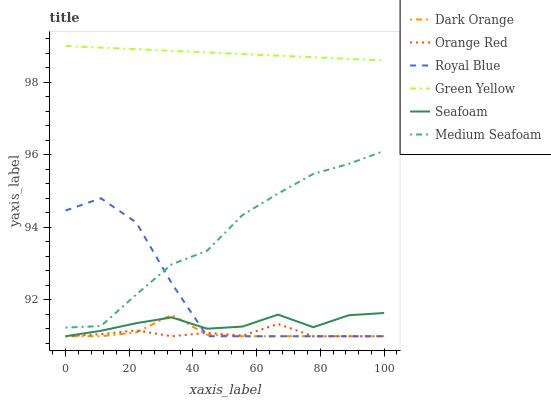Does Orange Red have the minimum area under the curve?
Answer yes or no. Yes. Does Green Yellow have the maximum area under the curve?
Answer yes or no. Yes. Does Seafoam have the minimum area under the curve?
Answer yes or no. No. Does Seafoam have the maximum area under the curve?
Answer yes or no. No. Is Green Yellow the smoothest?
Answer yes or no. Yes. Is Royal Blue the roughest?
Answer yes or no. Yes. Is Seafoam the smoothest?
Answer yes or no. No. Is Seafoam the roughest?
Answer yes or no. No. Does Dark Orange have the lowest value?
Answer yes or no. Yes. Does Green Yellow have the lowest value?
Answer yes or no. No. Does Green Yellow have the highest value?
Answer yes or no. Yes. Does Seafoam have the highest value?
Answer yes or no. No. Is Seafoam less than Medium Seafoam?
Answer yes or no. Yes. Is Green Yellow greater than Orange Red?
Answer yes or no. Yes. Does Dark Orange intersect Orange Red?
Answer yes or no. Yes. Is Dark Orange less than Orange Red?
Answer yes or no. No. Is Dark Orange greater than Orange Red?
Answer yes or no. No. Does Seafoam intersect Medium Seafoam?
Answer yes or no. No. 